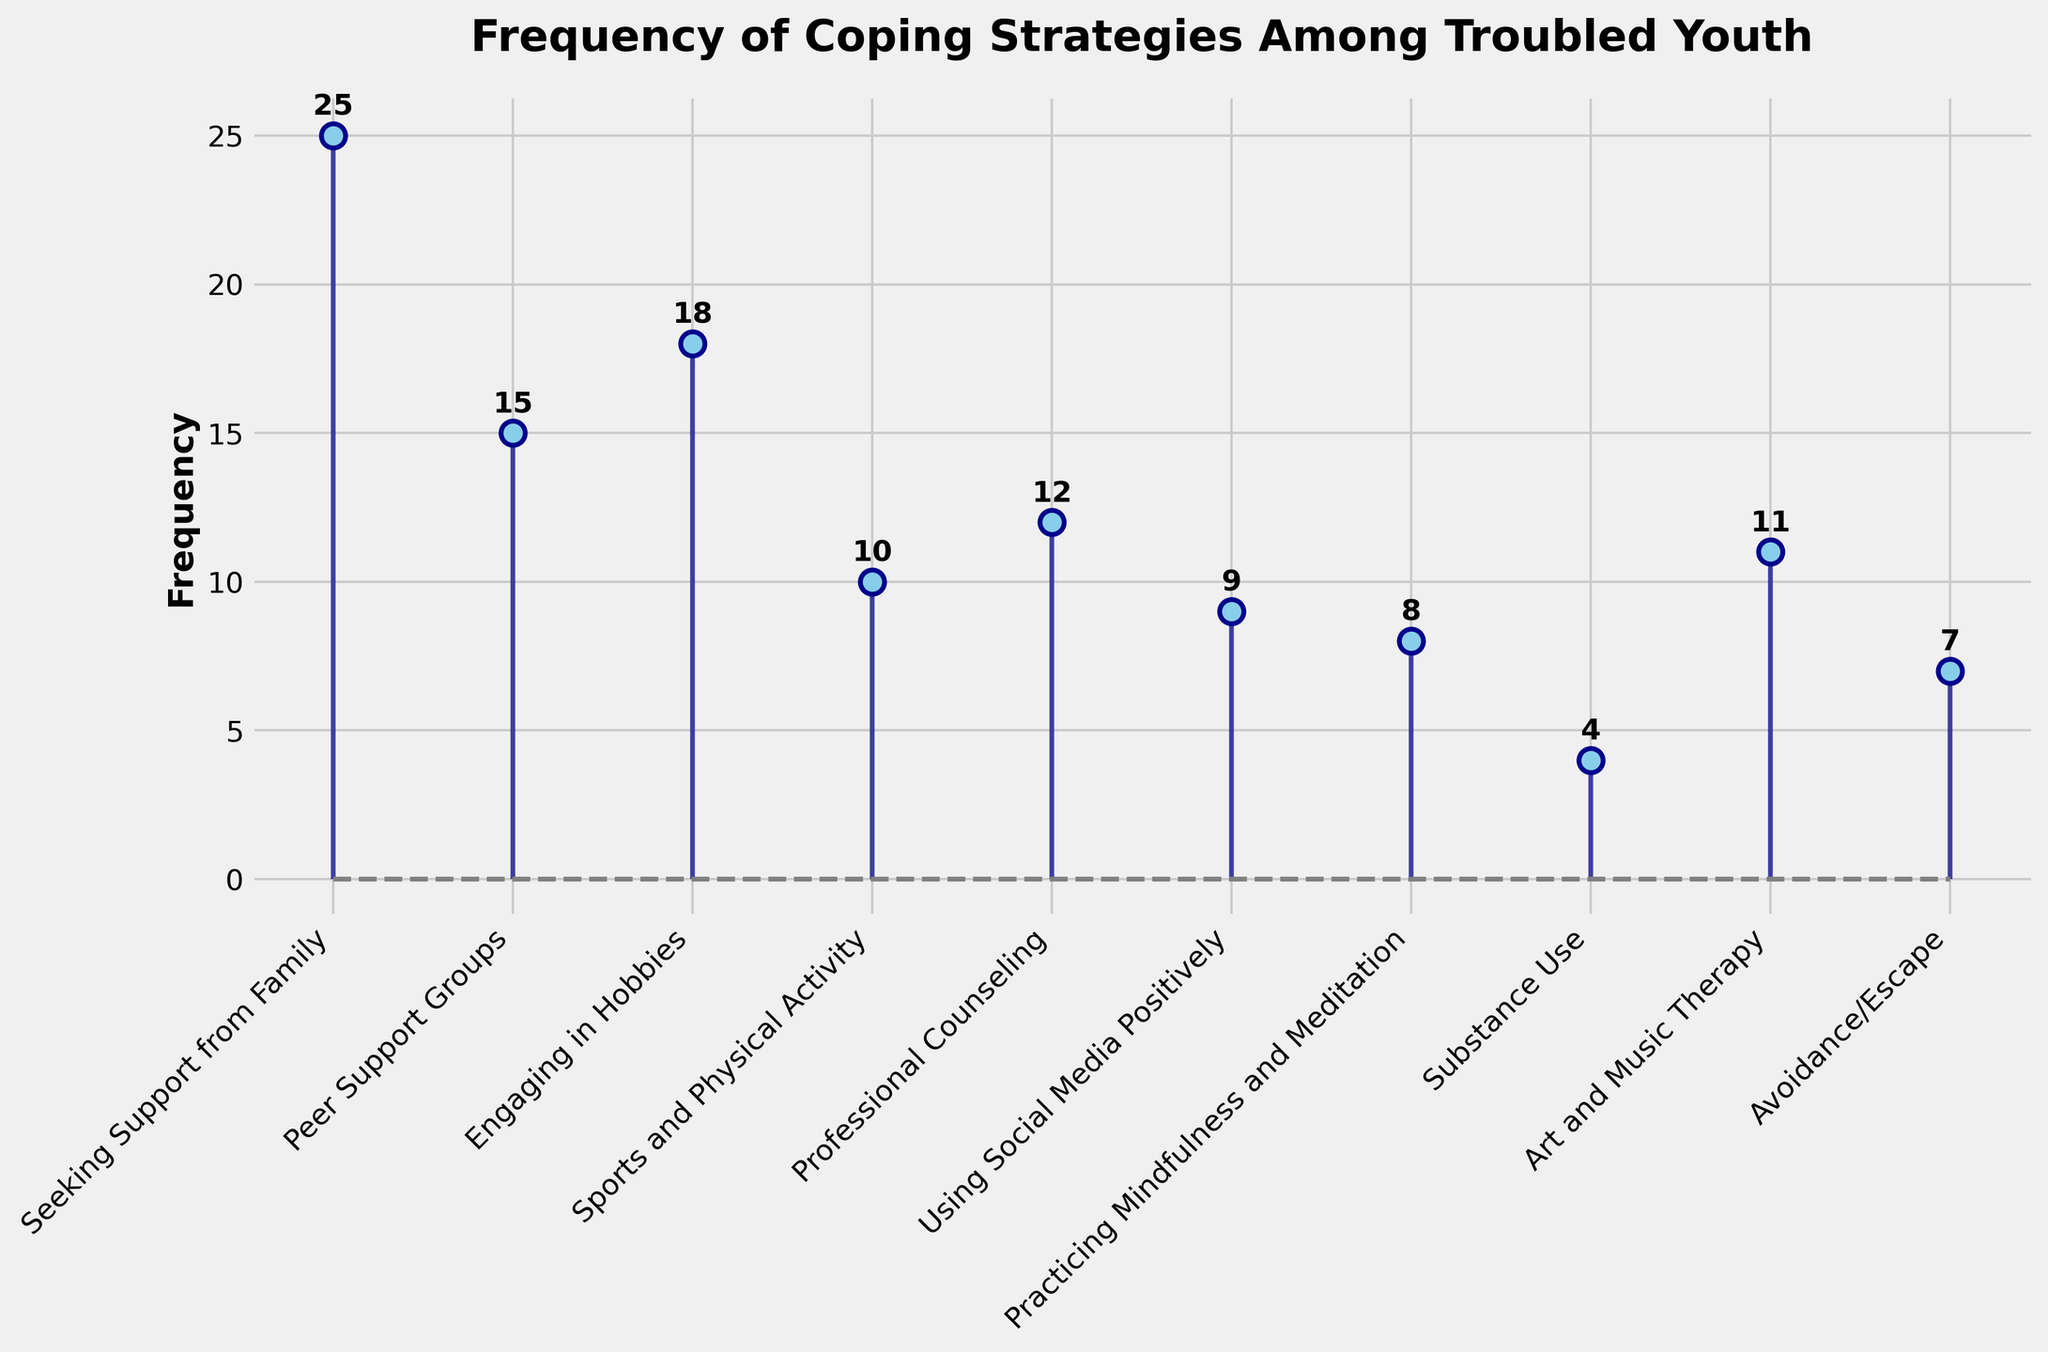What is the title of the plot? The title is usually displayed at the top of the figure. By looking at the figure, we can see the title is "Frequency of Coping Strategies Among Troubled Youth".
Answer: Frequency of Coping Strategies Among Troubled Youth What is the coping strategy with the highest frequency? By observing the stems and the labels on the x-axis, we see that "Seeking Support from Family" has the highest height in the plot. The corresponding text indicates it has a frequency of 25.
Answer: Seeking Support from Family How many coping strategies have a frequency greater than 10? Looking at the stems and their corresponding y-axis values, we see that "Seeking Support from Family (25)", "Peer Support Groups (15)", "Engaging in Hobbies (18)", "Professional Counseling (12)", and "Art and Music Therapy (11)" are above 10. There are five such strategies.
Answer: 5 Which coping strategy has the lowest frequency? By identifying the stem with the shortest height, we see that "Substance Use" has the lowest value. The corresponding text indicates a frequency of 4.
Answer: Substance Use What is the total frequency of the top three coping strategies? The top three strategies by frequency are "Seeking Support from Family (25)", "Engaging in Hobbies (18)", and "Peer Support Groups (15)". Adding these values gives 25 + 18 + 15 = 58.
Answer: 58 How many coping strategies have a frequency less than 10? By examining the labels and the y-axis values, we see that "Using Social Media Positively (9)", "Practicing Mindfulness and Meditation (8)", "Avoidance/Escape (7)", and "Substance Use (4)" are less than 10. There are four such strategies.
Answer: 4 What is the difference in frequency between "Engaging in Hobbies" and "Sports and Physical Activity"? The frequency of "Engaging in Hobbies" is 18, and for "Sports and Physical Activity" it is 10. The difference is 18 - 10 = 8.
Answer: 8 Which strategies have a frequency that is equal to or less than the average frequency of all strategies? First, calculate the average frequency by summing all frequencies and dividing by the number of strategies. Sum = 25 + 15 + 18 + 10 + 12 + 9 + 8 + 4 + 11 + 7 = 119. The number of strategies is 10, so the average frequency is 119/10 = 11.9. The strategies with a frequency equal to or less than 11.9 are "Sports and Physical Activity (10)", "Professional Counseling (12)", "Using Social Media Positively (9)", "Practicing Mindfulness and Meditation (8)", "Art and Music Therapy (11)", "Avoidance/Escape (7)", and "Substance Use (4)".
Answer: Sports and Physical Activity, Professional Counseling, Using Social Media Positively, Practicing Mindfulness and Meditation, Art and Music Therapy, Avoidance/Escape, Substance Use What is the median frequency of the coping strategies? List the frequencies in ascending order: 4, 7, 8, 9, 10, 11, 12, 15, 18, 25. With an even number of data points, the median is the average of the two middle values, which are 10 and 11. (10 + 11) / 2 = 10.5.
Answer: 10.5 